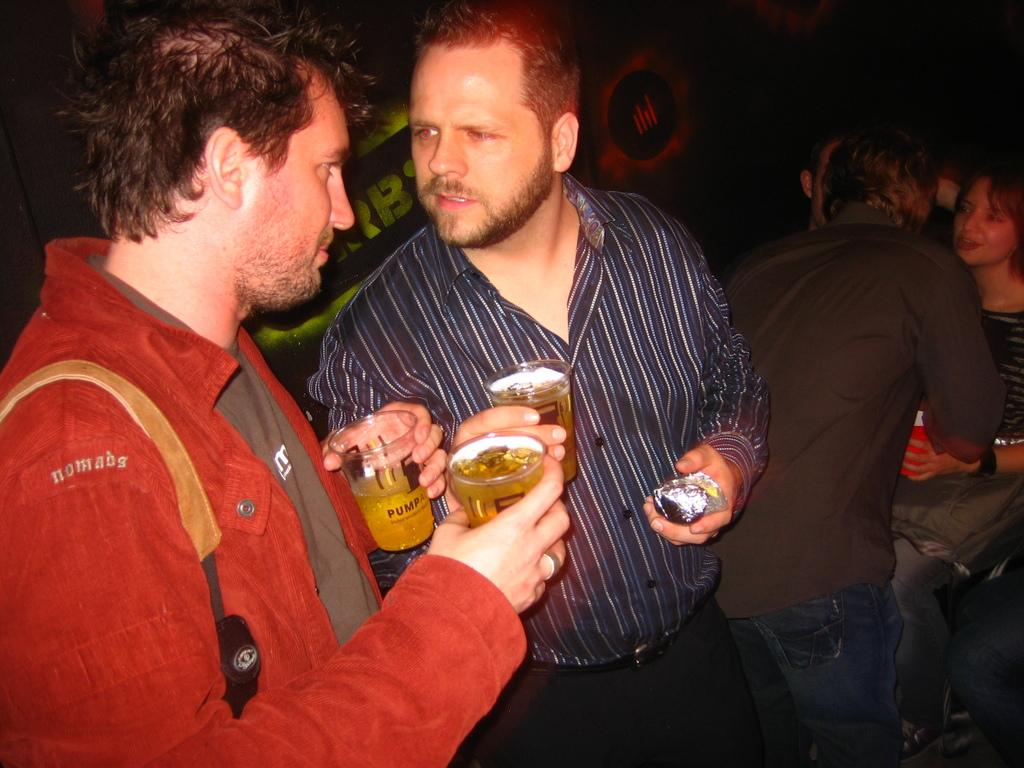What are the two people in the image holding? The two people in the image are holding wine glasses. Can you describe the other people present in the image? There are other people present in the image, but their specific actions or features are not mentioned in the provided facts. What can be seen in the background of the image? Screens are visible in the background of the image. What type of poison is the crow drinking from the sheet in the image? There is no crow, poison, or sheet present in the image. 